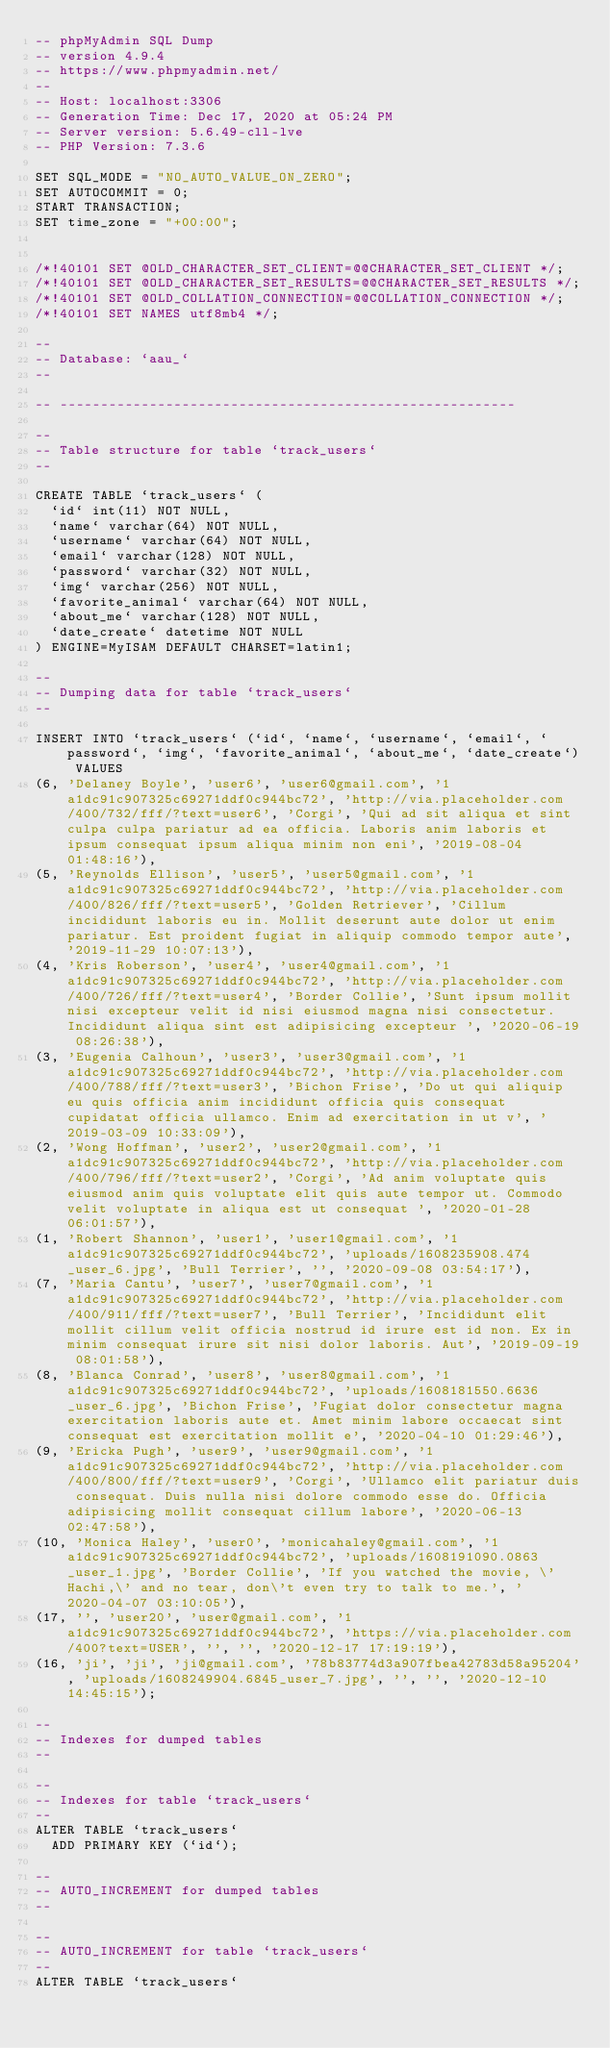<code> <loc_0><loc_0><loc_500><loc_500><_SQL_>-- phpMyAdmin SQL Dump
-- version 4.9.4
-- https://www.phpmyadmin.net/
--
-- Host: localhost:3306
-- Generation Time: Dec 17, 2020 at 05:24 PM
-- Server version: 5.6.49-cll-lve
-- PHP Version: 7.3.6

SET SQL_MODE = "NO_AUTO_VALUE_ON_ZERO";
SET AUTOCOMMIT = 0;
START TRANSACTION;
SET time_zone = "+00:00";


/*!40101 SET @OLD_CHARACTER_SET_CLIENT=@@CHARACTER_SET_CLIENT */;
/*!40101 SET @OLD_CHARACTER_SET_RESULTS=@@CHARACTER_SET_RESULTS */;
/*!40101 SET @OLD_COLLATION_CONNECTION=@@COLLATION_CONNECTION */;
/*!40101 SET NAMES utf8mb4 */;

--
-- Database: `aau_`
--

-- --------------------------------------------------------

--
-- Table structure for table `track_users`
--

CREATE TABLE `track_users` (
  `id` int(11) NOT NULL,
  `name` varchar(64) NOT NULL,
  `username` varchar(64) NOT NULL,
  `email` varchar(128) NOT NULL,
  `password` varchar(32) NOT NULL,
  `img` varchar(256) NOT NULL,
  `favorite_animal` varchar(64) NOT NULL,
  `about_me` varchar(128) NOT NULL,
  `date_create` datetime NOT NULL
) ENGINE=MyISAM DEFAULT CHARSET=latin1;

--
-- Dumping data for table `track_users`
--

INSERT INTO `track_users` (`id`, `name`, `username`, `email`, `password`, `img`, `favorite_animal`, `about_me`, `date_create`) VALUES
(6, 'Delaney Boyle', 'user6', 'user6@gmail.com', '1a1dc91c907325c69271ddf0c944bc72', 'http://via.placeholder.com/400/732/fff/?text=user6', 'Corgi', 'Qui ad sit aliqua et sint culpa culpa pariatur ad ea officia. Laboris anim laboris et ipsum consequat ipsum aliqua minim non eni', '2019-08-04 01:48:16'),
(5, 'Reynolds Ellison', 'user5', 'user5@gmail.com', '1a1dc91c907325c69271ddf0c944bc72', 'http://via.placeholder.com/400/826/fff/?text=user5', 'Golden Retriever', 'Cillum incididunt laboris eu in. Mollit deserunt aute dolor ut enim pariatur. Est proident fugiat in aliquip commodo tempor aute', '2019-11-29 10:07:13'),
(4, 'Kris Roberson', 'user4', 'user4@gmail.com', '1a1dc91c907325c69271ddf0c944bc72', 'http://via.placeholder.com/400/726/fff/?text=user4', 'Border Collie', 'Sunt ipsum mollit nisi excepteur velit id nisi eiusmod magna nisi consectetur. Incididunt aliqua sint est adipisicing excepteur ', '2020-06-19 08:26:38'),
(3, 'Eugenia Calhoun', 'user3', 'user3@gmail.com', '1a1dc91c907325c69271ddf0c944bc72', 'http://via.placeholder.com/400/788/fff/?text=user3', 'Bichon Frise', 'Do ut qui aliquip eu quis officia anim incididunt officia quis consequat cupidatat officia ullamco. Enim ad exercitation in ut v', '2019-03-09 10:33:09'),
(2, 'Wong Hoffman', 'user2', 'user2@gmail.com', '1a1dc91c907325c69271ddf0c944bc72', 'http://via.placeholder.com/400/796/fff/?text=user2', 'Corgi', 'Ad anim voluptate quis eiusmod anim quis voluptate elit quis aute tempor ut. Commodo velit voluptate in aliqua est ut consequat ', '2020-01-28 06:01:57'),
(1, 'Robert Shannon', 'user1', 'user1@gmail.com', '1a1dc91c907325c69271ddf0c944bc72', 'uploads/1608235908.474_user_6.jpg', 'Bull Terrier', '', '2020-09-08 03:54:17'),
(7, 'Maria Cantu', 'user7', 'user7@gmail.com', '1a1dc91c907325c69271ddf0c944bc72', 'http://via.placeholder.com/400/911/fff/?text=user7', 'Bull Terrier', 'Incididunt elit mollit cillum velit officia nostrud id irure est id non. Ex in minim consequat irure sit nisi dolor laboris. Aut', '2019-09-19 08:01:58'),
(8, 'Blanca Conrad', 'user8', 'user8@gmail.com', '1a1dc91c907325c69271ddf0c944bc72', 'uploads/1608181550.6636_user_6.jpg', 'Bichon Frise', 'Fugiat dolor consectetur magna exercitation laboris aute et. Amet minim labore occaecat sint consequat est exercitation mollit e', '2020-04-10 01:29:46'),
(9, 'Ericka Pugh', 'user9', 'user9@gmail.com', '1a1dc91c907325c69271ddf0c944bc72', 'http://via.placeholder.com/400/800/fff/?text=user9', 'Corgi', 'Ullamco elit pariatur duis consequat. Duis nulla nisi dolore commodo esse do. Officia adipisicing mollit consequat cillum labore', '2020-06-13 02:47:58'),
(10, 'Monica Haley', 'user0', 'monicahaley@gmail.com', '1a1dc91c907325c69271ddf0c944bc72', 'uploads/1608191090.0863_user_1.jpg', 'Border Collie', 'If you watched the movie, \'Hachi,\' and no tear, don\'t even try to talk to me.', '2020-04-07 03:10:05'),
(17, '', 'user20', 'user@gmail.com', '1a1dc91c907325c69271ddf0c944bc72', 'https://via.placeholder.com/400?text=USER', '', '', '2020-12-17 17:19:19'),
(16, 'ji', 'ji', 'ji@gmail.com', '78b83774d3a907fbea42783d58a95204', 'uploads/1608249904.6845_user_7.jpg', '', '', '2020-12-10 14:45:15');

--
-- Indexes for dumped tables
--

--
-- Indexes for table `track_users`
--
ALTER TABLE `track_users`
  ADD PRIMARY KEY (`id`);

--
-- AUTO_INCREMENT for dumped tables
--

--
-- AUTO_INCREMENT for table `track_users`
--
ALTER TABLE `track_users`</code> 